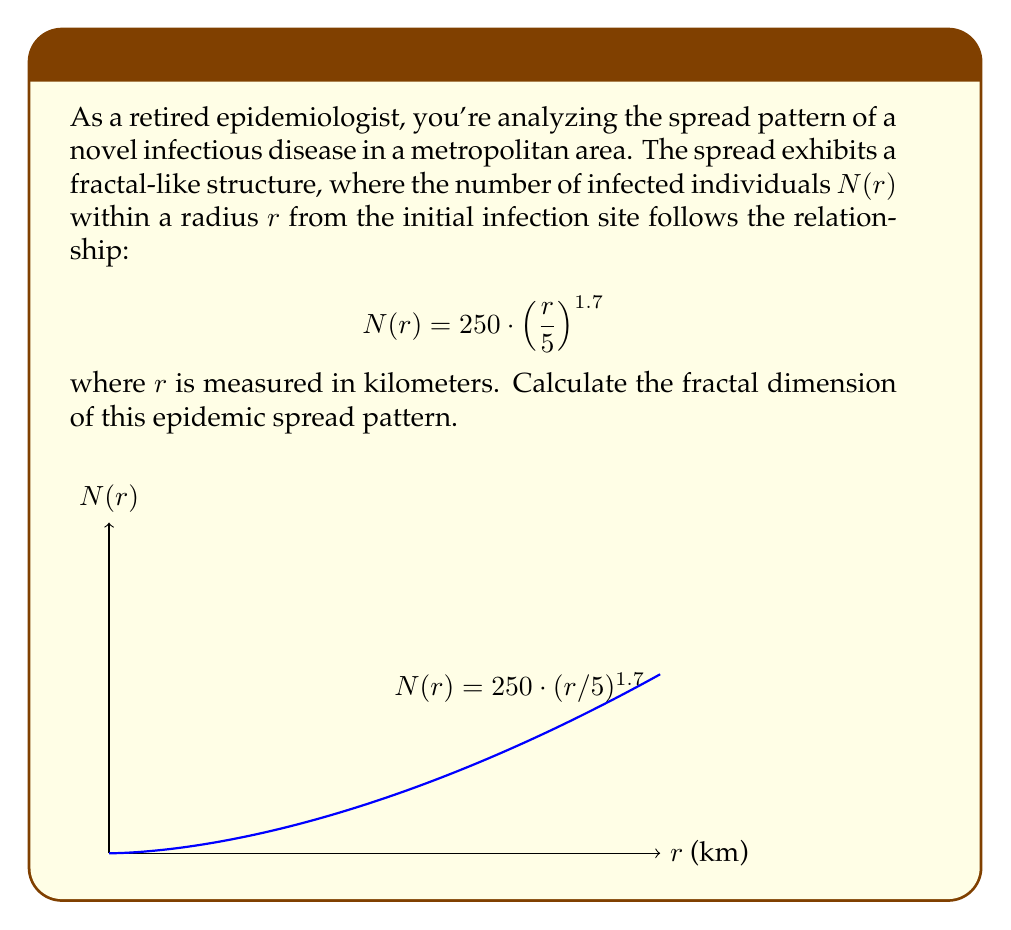Show me your answer to this math problem. To calculate the fractal dimension of the epidemic spread pattern, we'll follow these steps:

1) The general form of a fractal relationship is:

   $$N(r) = k \cdot r^D$$

   where $D$ is the fractal dimension.

2) In our case, we have:

   $$N(r) = 250 \cdot \left(\frac{r}{5}\right)^{1.7}$$

3) We can rewrite this as:

   $$N(r) = 250 \cdot 5^{-1.7} \cdot r^{1.7}$$

4) Comparing this to the general form, we can see that:

   $k = 250 \cdot 5^{-1.7}$
   $D = 1.7$

5) Therefore, the fractal dimension of the epidemic spread pattern is 1.7.

This fractal dimension indicates that the spread pattern is more space-filling than a simple line (dimension 1) but less than a filled plane (dimension 2). This is typical for epidemic spread in urban areas, where the pattern is influenced by population density and movement patterns.
Answer: $D = 1.7$ 